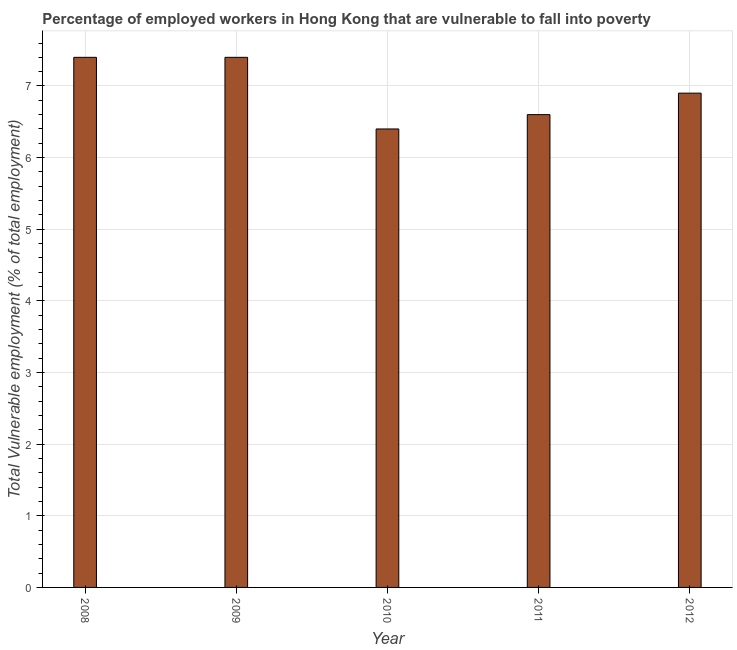Does the graph contain any zero values?
Your answer should be compact. No. What is the title of the graph?
Your answer should be compact. Percentage of employed workers in Hong Kong that are vulnerable to fall into poverty. What is the label or title of the Y-axis?
Keep it short and to the point. Total Vulnerable employment (% of total employment). What is the total vulnerable employment in 2008?
Keep it short and to the point. 7.4. Across all years, what is the maximum total vulnerable employment?
Provide a succinct answer. 7.4. Across all years, what is the minimum total vulnerable employment?
Offer a terse response. 6.4. In which year was the total vulnerable employment maximum?
Offer a very short reply. 2008. In which year was the total vulnerable employment minimum?
Your answer should be compact. 2010. What is the sum of the total vulnerable employment?
Your answer should be very brief. 34.7. What is the average total vulnerable employment per year?
Ensure brevity in your answer.  6.94. What is the median total vulnerable employment?
Ensure brevity in your answer.  6.9. What is the ratio of the total vulnerable employment in 2009 to that in 2010?
Provide a short and direct response. 1.16. What is the difference between the highest and the lowest total vulnerable employment?
Your answer should be compact. 1. In how many years, is the total vulnerable employment greater than the average total vulnerable employment taken over all years?
Your response must be concise. 2. What is the difference between two consecutive major ticks on the Y-axis?
Make the answer very short. 1. What is the Total Vulnerable employment (% of total employment) of 2008?
Your response must be concise. 7.4. What is the Total Vulnerable employment (% of total employment) in 2009?
Provide a short and direct response. 7.4. What is the Total Vulnerable employment (% of total employment) of 2010?
Offer a terse response. 6.4. What is the Total Vulnerable employment (% of total employment) of 2011?
Offer a terse response. 6.6. What is the Total Vulnerable employment (% of total employment) in 2012?
Make the answer very short. 6.9. What is the difference between the Total Vulnerable employment (% of total employment) in 2009 and 2010?
Keep it short and to the point. 1. What is the difference between the Total Vulnerable employment (% of total employment) in 2009 and 2011?
Keep it short and to the point. 0.8. What is the difference between the Total Vulnerable employment (% of total employment) in 2009 and 2012?
Offer a very short reply. 0.5. What is the difference between the Total Vulnerable employment (% of total employment) in 2010 and 2012?
Your response must be concise. -0.5. What is the difference between the Total Vulnerable employment (% of total employment) in 2011 and 2012?
Offer a very short reply. -0.3. What is the ratio of the Total Vulnerable employment (% of total employment) in 2008 to that in 2010?
Your response must be concise. 1.16. What is the ratio of the Total Vulnerable employment (% of total employment) in 2008 to that in 2011?
Provide a succinct answer. 1.12. What is the ratio of the Total Vulnerable employment (% of total employment) in 2008 to that in 2012?
Your answer should be very brief. 1.07. What is the ratio of the Total Vulnerable employment (% of total employment) in 2009 to that in 2010?
Give a very brief answer. 1.16. What is the ratio of the Total Vulnerable employment (% of total employment) in 2009 to that in 2011?
Offer a very short reply. 1.12. What is the ratio of the Total Vulnerable employment (% of total employment) in 2009 to that in 2012?
Your answer should be compact. 1.07. What is the ratio of the Total Vulnerable employment (% of total employment) in 2010 to that in 2011?
Provide a succinct answer. 0.97. What is the ratio of the Total Vulnerable employment (% of total employment) in 2010 to that in 2012?
Give a very brief answer. 0.93. What is the ratio of the Total Vulnerable employment (% of total employment) in 2011 to that in 2012?
Offer a very short reply. 0.96. 